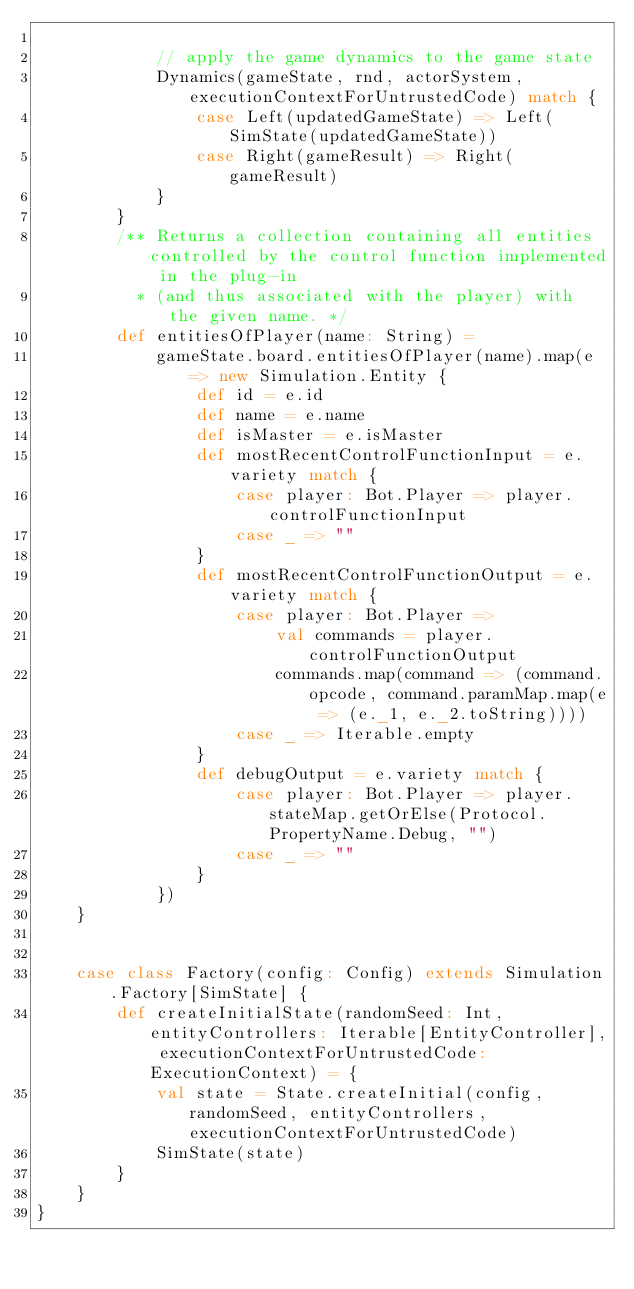Convert code to text. <code><loc_0><loc_0><loc_500><loc_500><_Scala_>
            // apply the game dynamics to the game state
            Dynamics(gameState, rnd, actorSystem, executionContextForUntrustedCode) match {
                case Left(updatedGameState) => Left(SimState(updatedGameState))
                case Right(gameResult) => Right(gameResult)
            }
        }
        /** Returns a collection containing all entities controlled by the control function implemented in the plug-in
          * (and thus associated with the player) with the given name. */
        def entitiesOfPlayer(name: String) =
            gameState.board.entitiesOfPlayer(name).map(e => new Simulation.Entity {
                def id = e.id
                def name = e.name
                def isMaster = e.isMaster
                def mostRecentControlFunctionInput = e.variety match {
                    case player: Bot.Player => player.controlFunctionInput
                    case _ => ""
                }
                def mostRecentControlFunctionOutput = e.variety match {
                    case player: Bot.Player =>
                        val commands = player.controlFunctionOutput
                        commands.map(command => (command.opcode, command.paramMap.map(e => (e._1, e._2.toString))))
                    case _ => Iterable.empty
                }
                def debugOutput = e.variety match {
                    case player: Bot.Player => player.stateMap.getOrElse(Protocol.PropertyName.Debug, "")
                    case _ => ""
                }
            })
    }


    case class Factory(config: Config) extends Simulation.Factory[SimState] {
        def createInitialState(randomSeed: Int, entityControllers: Iterable[EntityController], executionContextForUntrustedCode: ExecutionContext) = {
            val state = State.createInitial(config, randomSeed, entityControllers, executionContextForUntrustedCode)
            SimState(state)
        }
    }
}</code> 